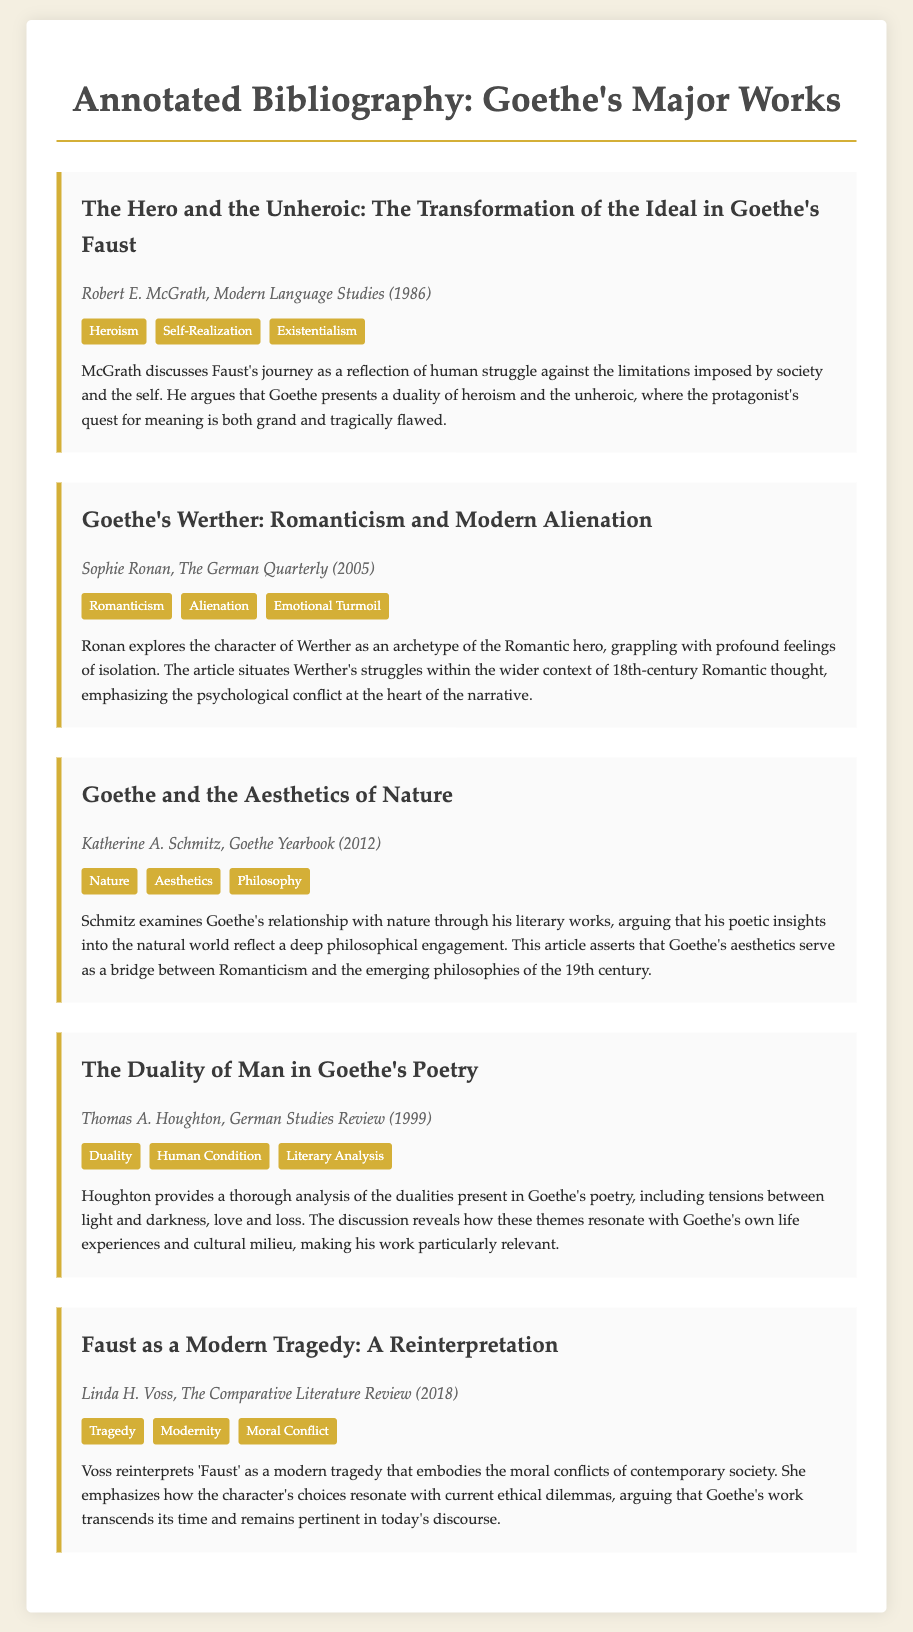What is the title of the first entry? The title of the first entry is presented prominently as the heading within the entry section.
Answer: The Hero and the Unheroic: The Transformation of the Ideal in Goethe's Faust Who is the author of the entry on Werther? The author's name is provided in the meta section of the entry.
Answer: Sophie Ronan In which year was "Faust as a Modern Tragedy: A Reinterpretation" published? The year of publication is listed in the meta details of that specific entry.
Answer: 2018 What theme is associated with Goethe's Werther according to Sophie Ronan? The themes are mentioned in the themes section for the entry on Werther, and one of them is specifically highlighted.
Answer: Alienation Which literary focus does Katherine A. Schmitz's entry revolve around? The main focus is indicated in the title and reinforced in the insights as discussed in the entry.
Answer: Nature How many themes are listed for "The Duality of Man in Goethe's Poetry"? The number of themes can be counted from the themes section of the corresponding entry.
Answer: Three What is a major insight provided by Linda H. Voss regarding Faust? The insights are summarized in a brief statement within the entry, highlighting key interpretations.
Answer: Modern tragedy Who published the entry discussing Goethe's relationship with nature? The author's name can be found in the meta details of that specific entry in the document.
Answer: Katherine A. Schmitz 